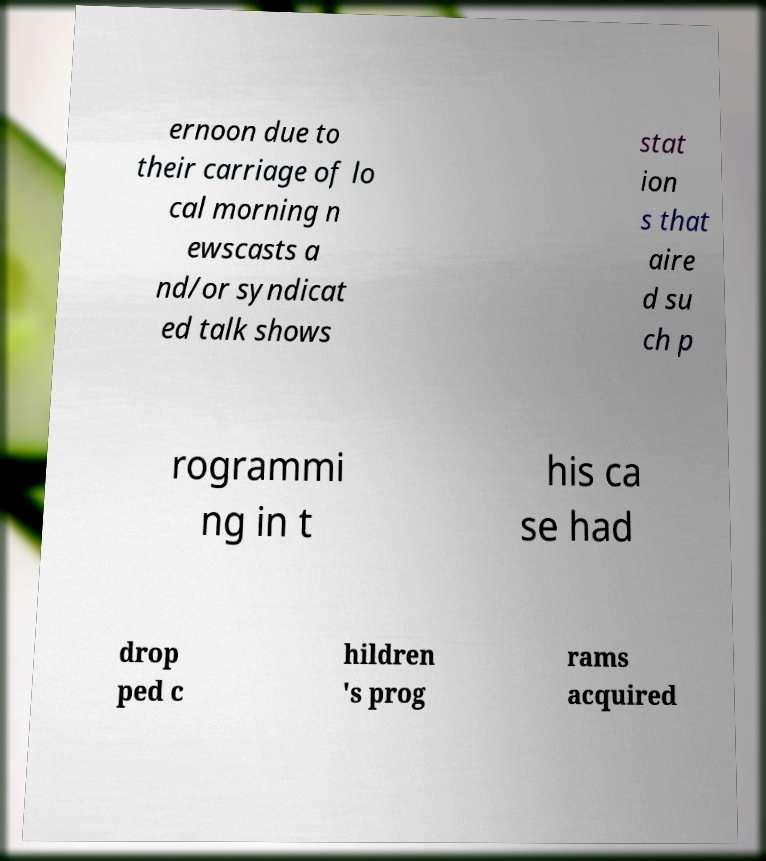Can you read and provide the text displayed in the image?This photo seems to have some interesting text. Can you extract and type it out for me? ernoon due to their carriage of lo cal morning n ewscasts a nd/or syndicat ed talk shows stat ion s that aire d su ch p rogrammi ng in t his ca se had drop ped c hildren 's prog rams acquired 